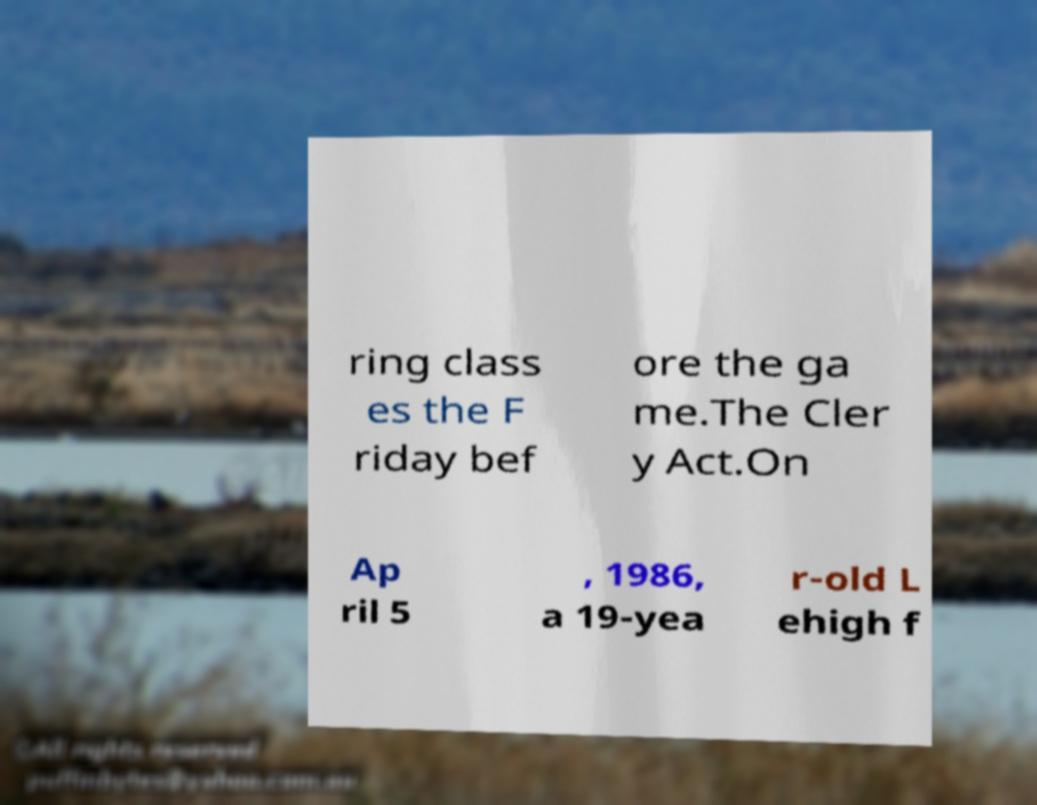Can you read and provide the text displayed in the image?This photo seems to have some interesting text. Can you extract and type it out for me? ring class es the F riday bef ore the ga me.The Cler y Act.On Ap ril 5 , 1986, a 19-yea r-old L ehigh f 